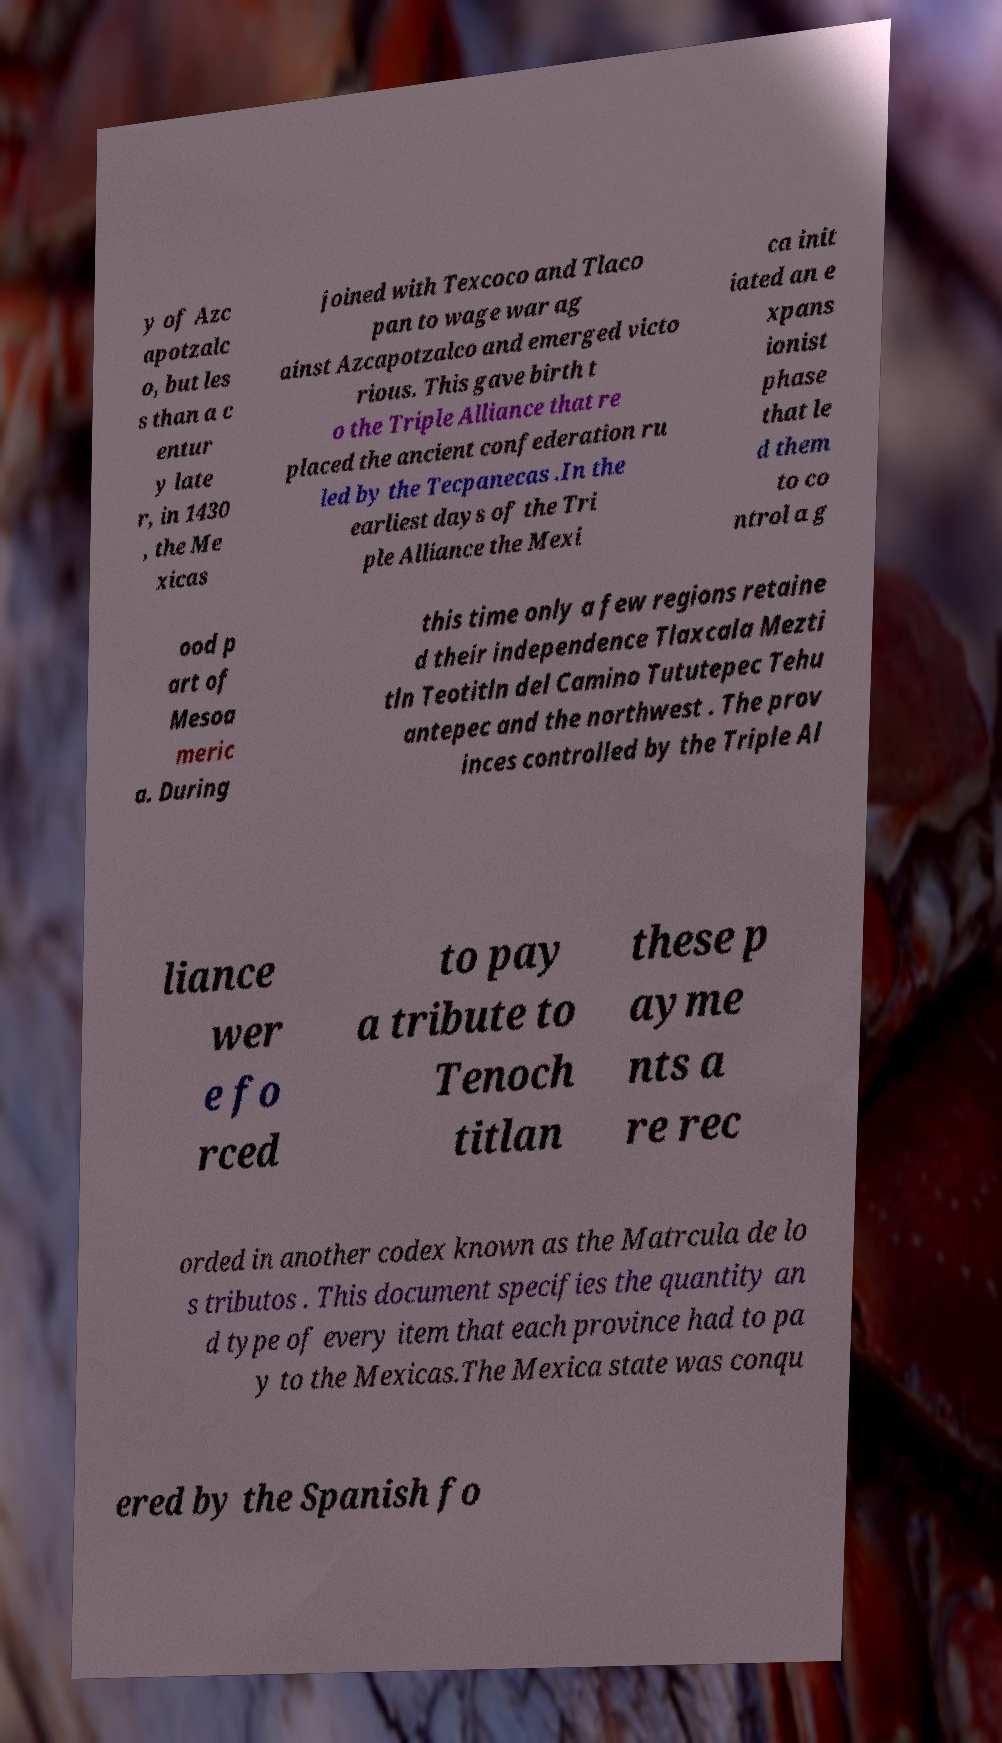Could you assist in decoding the text presented in this image and type it out clearly? y of Azc apotzalc o, but les s than a c entur y late r, in 1430 , the Me xicas joined with Texcoco and Tlaco pan to wage war ag ainst Azcapotzalco and emerged victo rious. This gave birth t o the Triple Alliance that re placed the ancient confederation ru led by the Tecpanecas .In the earliest days of the Tri ple Alliance the Mexi ca init iated an e xpans ionist phase that le d them to co ntrol a g ood p art of Mesoa meric a. During this time only a few regions retaine d their independence Tlaxcala Mezti tln Teotitln del Camino Tututepec Tehu antepec and the northwest . The prov inces controlled by the Triple Al liance wer e fo rced to pay a tribute to Tenoch titlan these p ayme nts a re rec orded in another codex known as the Matrcula de lo s tributos . This document specifies the quantity an d type of every item that each province had to pa y to the Mexicas.The Mexica state was conqu ered by the Spanish fo 